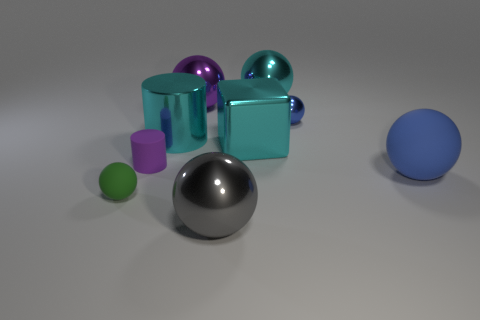Subtract all tiny green matte spheres. How many spheres are left? 5 Subtract all green balls. How many balls are left? 5 Subtract all purple balls. Subtract all red cylinders. How many balls are left? 5 Add 1 tiny red balls. How many objects exist? 10 Subtract all cylinders. How many objects are left? 7 Subtract all big gray things. Subtract all cyan metal objects. How many objects are left? 5 Add 7 matte balls. How many matte balls are left? 9 Add 5 big yellow cylinders. How many big yellow cylinders exist? 5 Subtract 1 green balls. How many objects are left? 8 